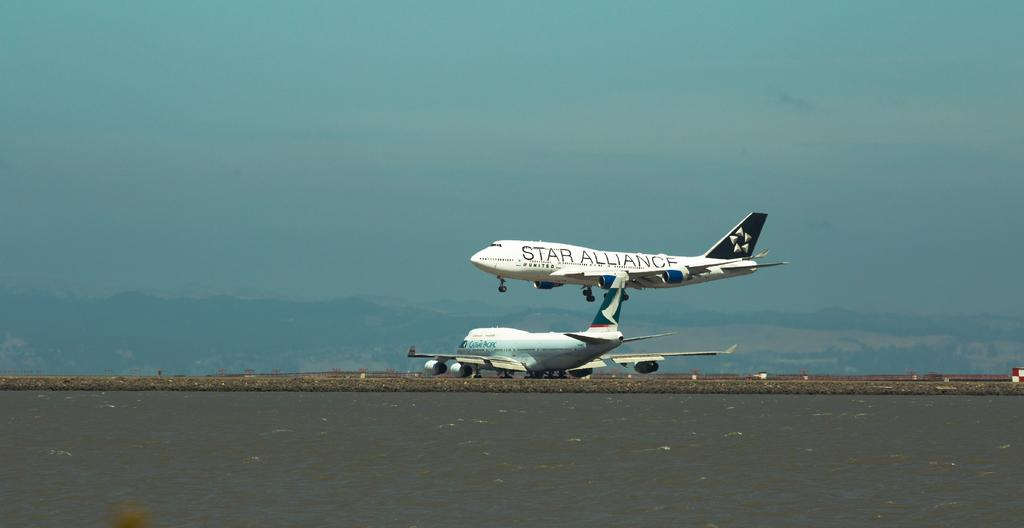<image>
Describe the image concisely. A plan taking off displaying the words Star Alliance 